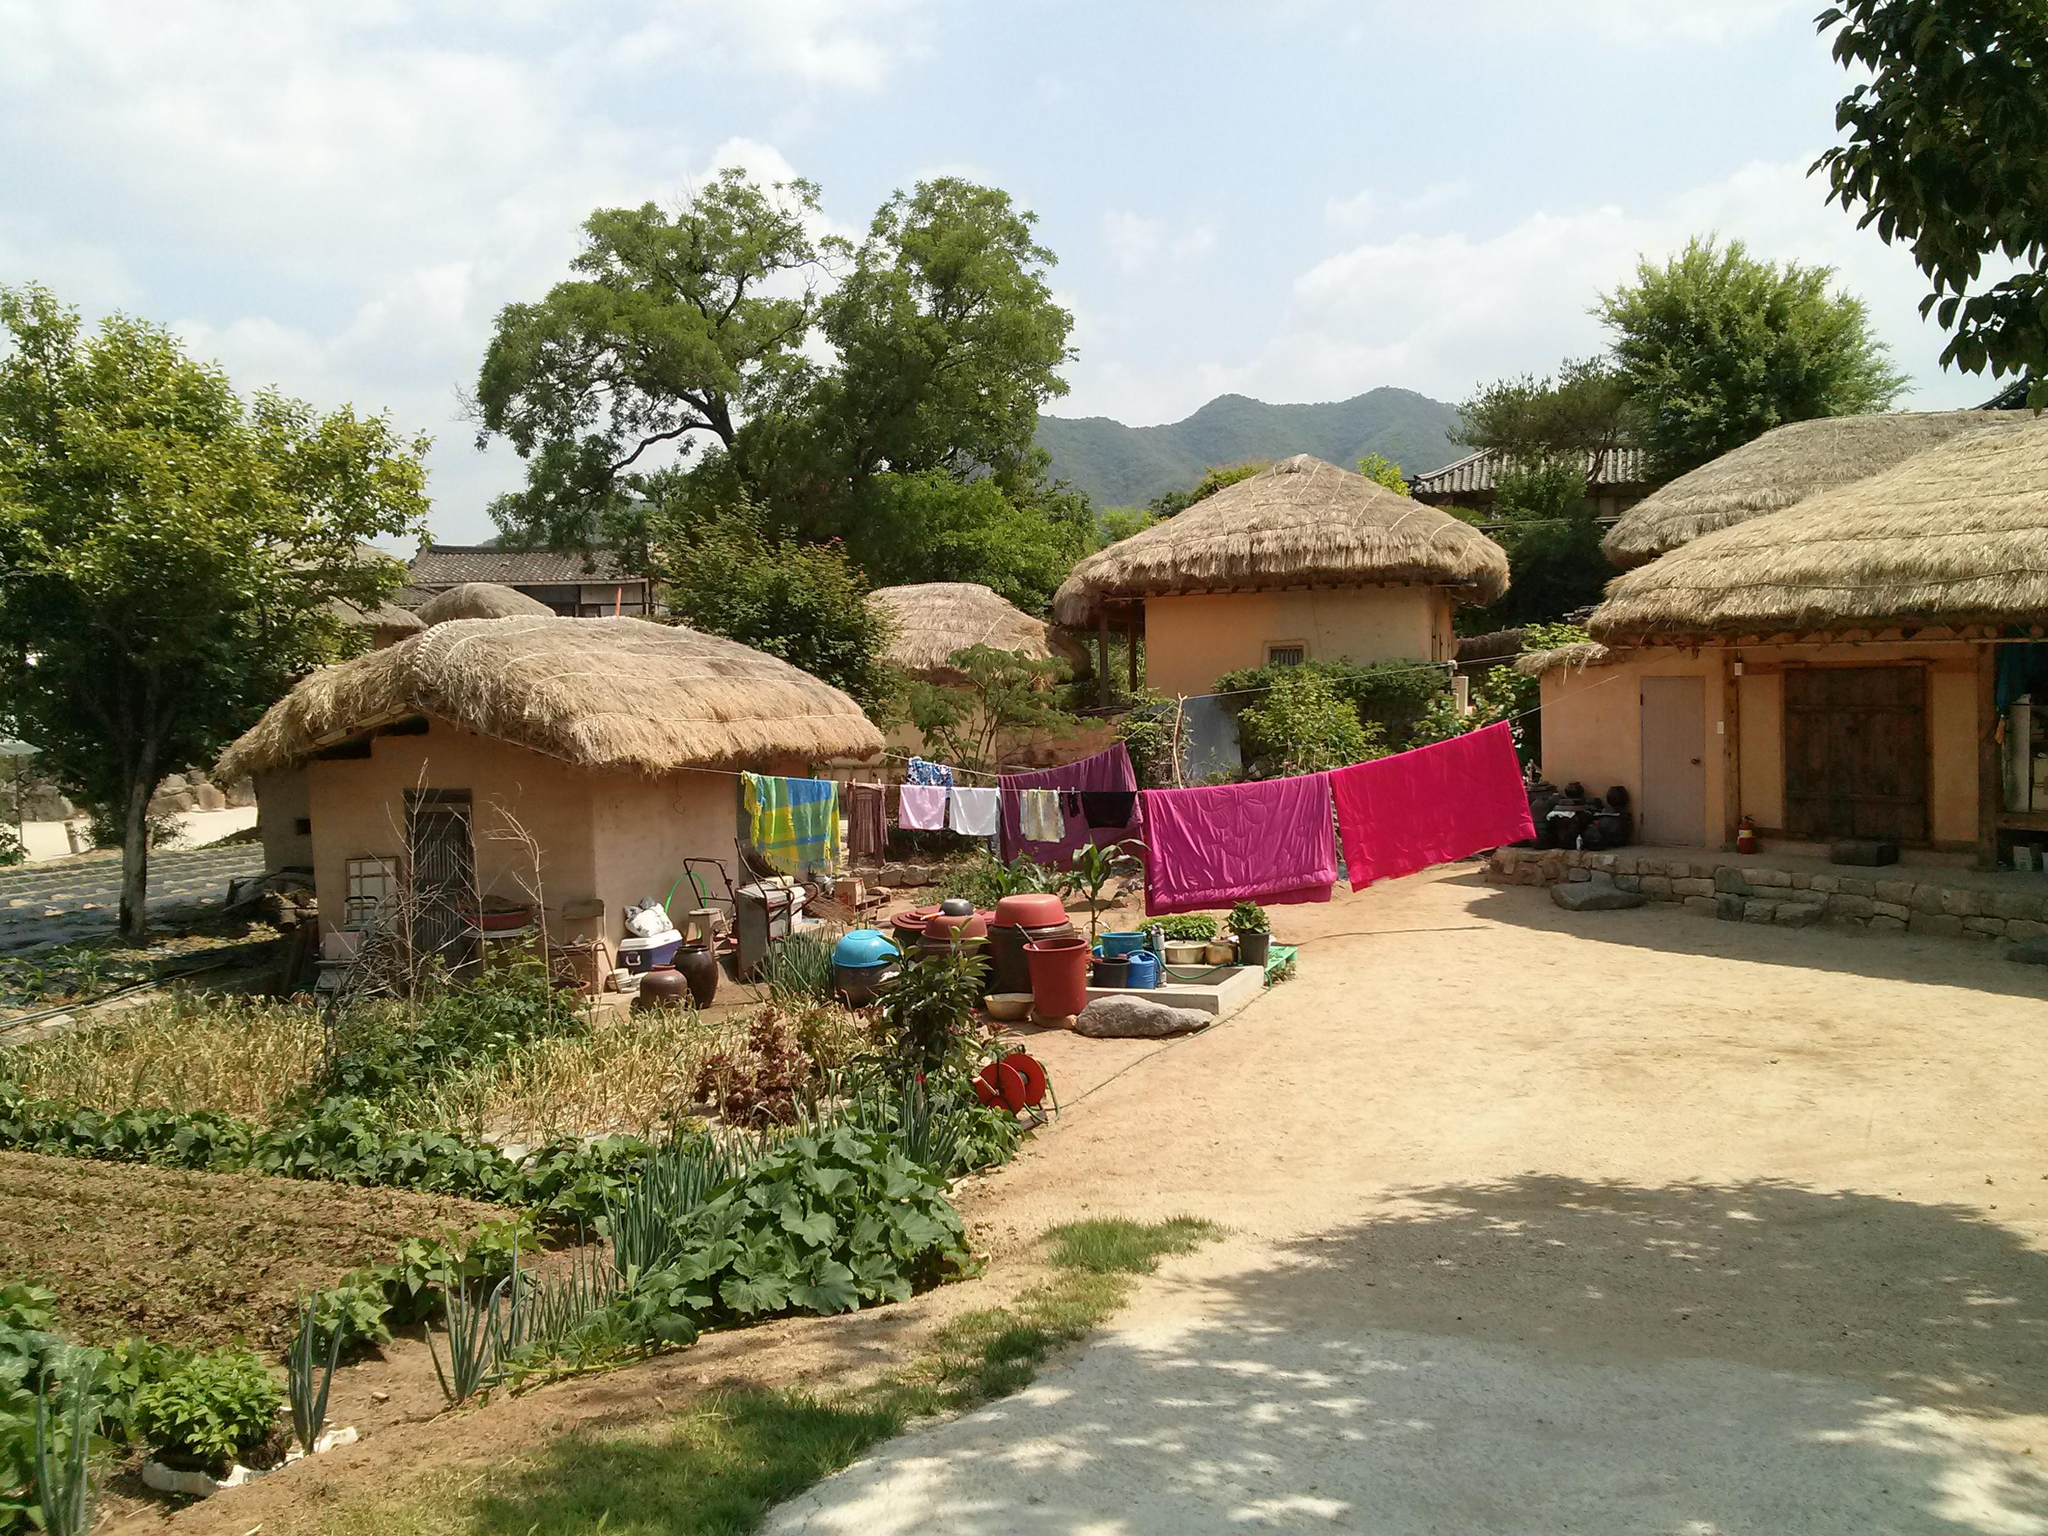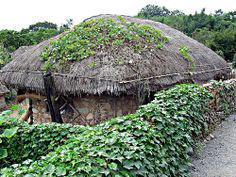The first image is the image on the left, the second image is the image on the right. For the images displayed, is the sentence "The left image shows a rock wall around at least one squarish building with smooth beige walls and a slightly peaked thatched roof." factually correct? Answer yes or no. No. The first image is the image on the left, the second image is the image on the right. Assess this claim about the two images: "In at least one image there is a hut with a roof made out of black straw.". Correct or not? Answer yes or no. Yes. 